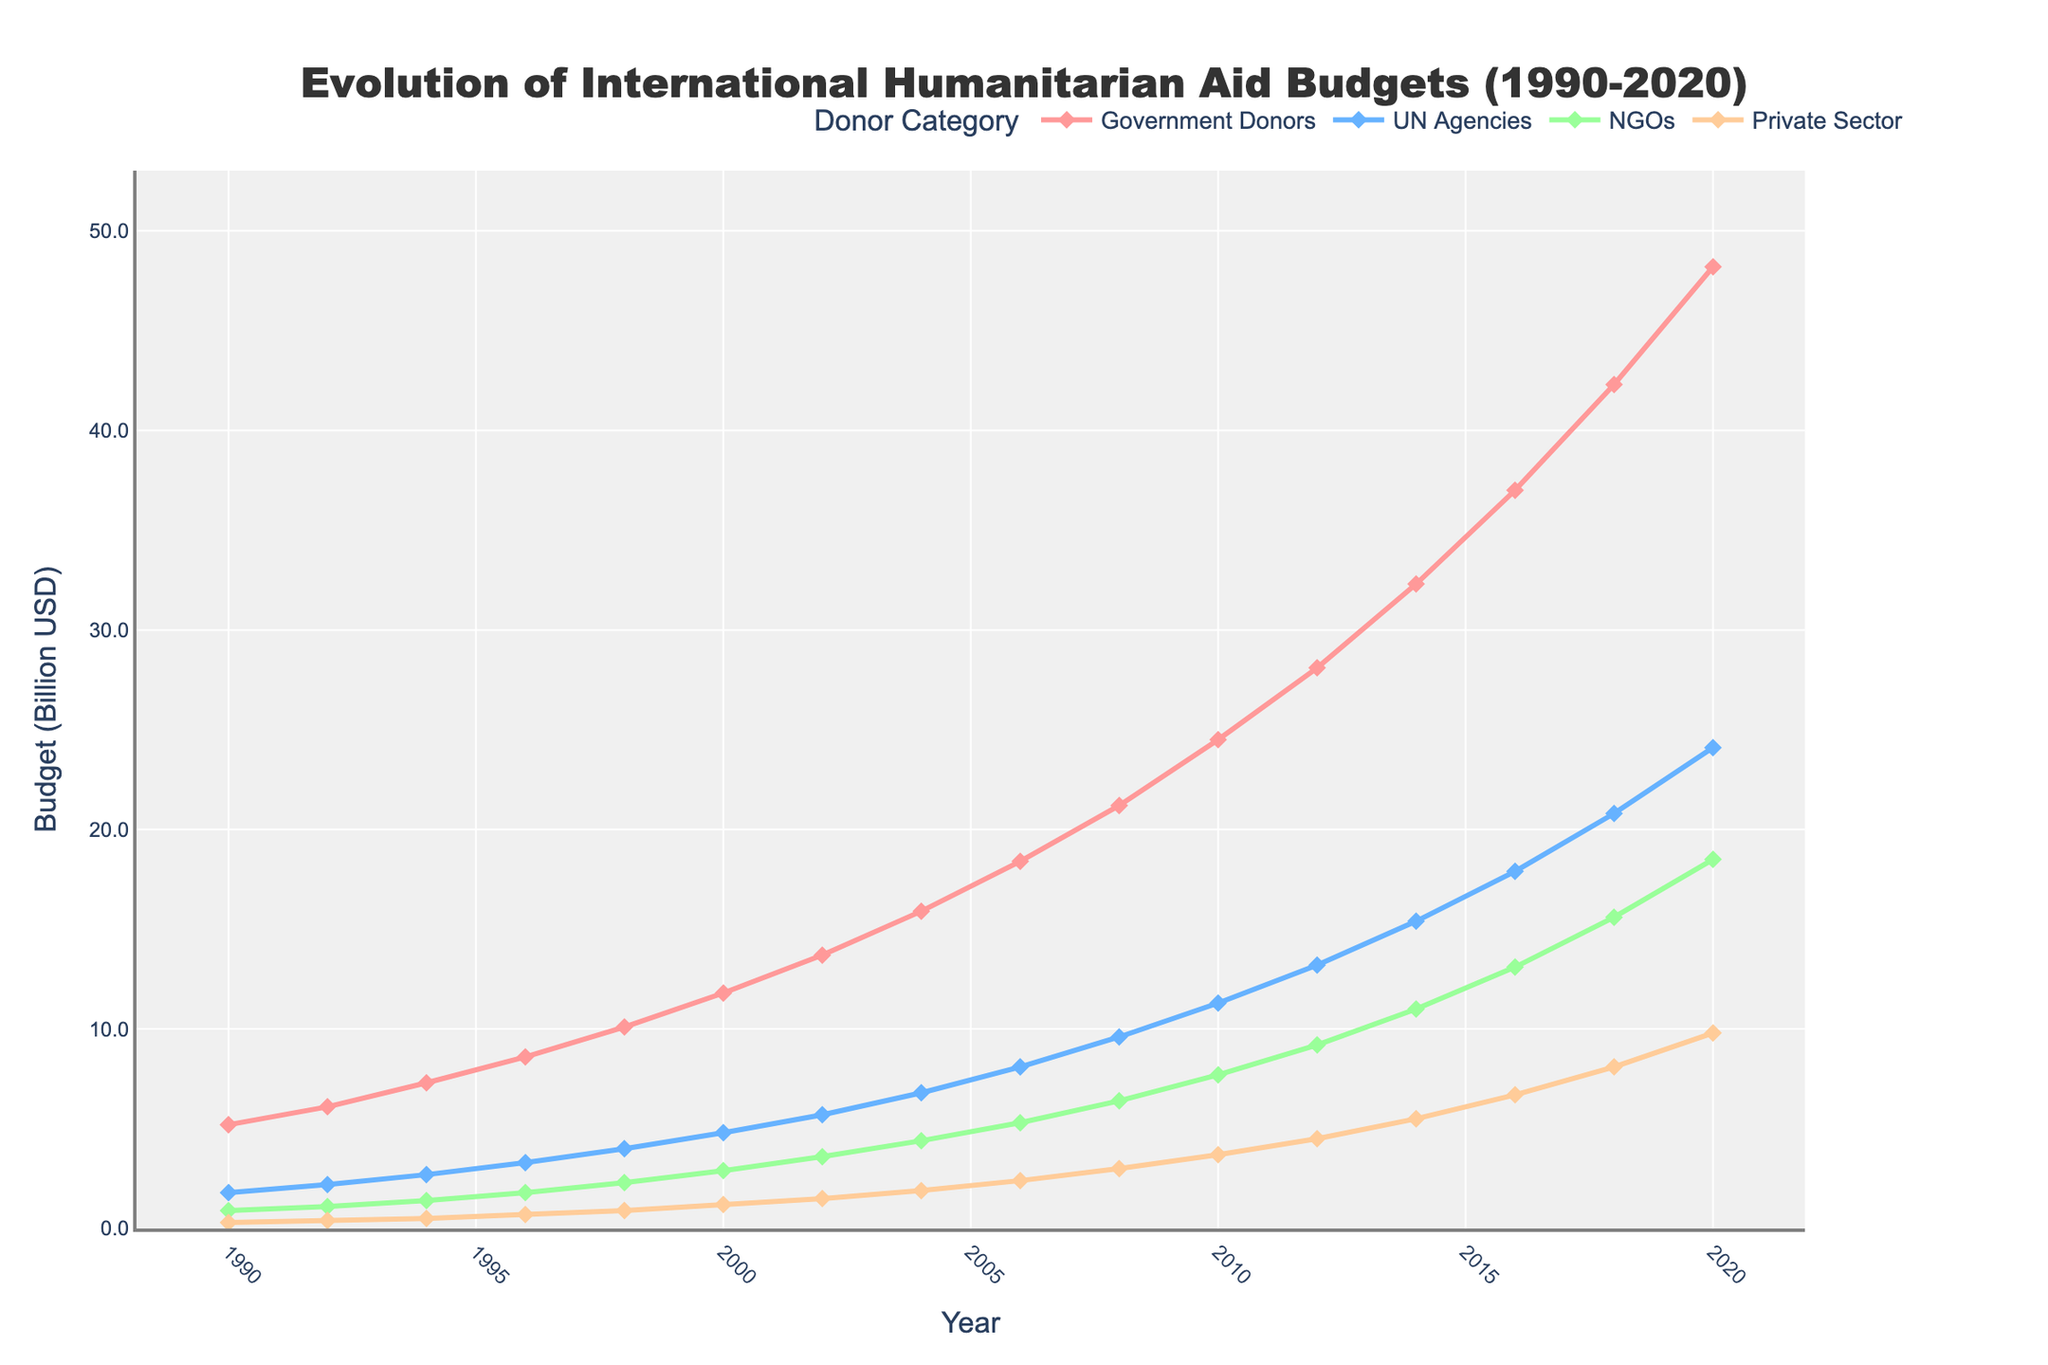What is the total humanitarian aid budget from all donors in 2000? To calculate the total, we sum the budget from Government Donors, UN Agencies, NGOs, and the Private Sector for the year 2000: 11.8 + 4.8 + 2.9 + 1.2 = 20.7
Answer: 20.7 Between 1996 and 2006, which donor category saw the greatest increase in their budget? To determine this, subtract the 1996 budgets from the 2006 budgets for each category: Government Donors (18.4 - 8.6 = 9.8), UN Agencies (8.1 - 3.3 = 4.8), NGOs (5.3 - 1.8 = 3.5), Private Sector (2.4 - 0.7 = 1.7). Government Donors saw the greatest increase of 9.8 billion USD.
Answer: Government Donors Which year does the aid budget from NGOs first exceed that of the Private Sector by more than 2 billion USD? Check the difference between NGOs and the Private Sector for each year: 2004 (4.4 - 1.9 = 2.5). NGOs first exceed the Private Sector by more than 2 billion USD in 2004.
Answer: 2004 What is the average annual budget for the UN Agencies from 1990 to 2020? Add all the annual budgets for UN Agencies and then divide by the number of years (16): (1.8 + 2.2+ 2.7 + 3.3 + 4.0 + 4.8 + 5.7 + 6.8 + 8.1 + 9.6 + 11.3 + 13.2 + 15.4 + 17.9 + 20.8 + 24.1)/16 = 9.46
Answer: 9.46 In which year did the total budget from the Private Sector exceed 7 billion USD? Looking at the data for the Private Sector, the first year the budget exceeds 7 billion USD is 2018, with 8.1 billion USD.
Answer: 2018 Which donor category had the smallest budget in 2016 and by how much? Comparing the 2016 data: Government Donors (37.0), UN Agencies (17.9), NGOs (13.1), Private Sector (6.7). The Private Sector had the smallest budget with 6.7 billion USD.
Answer: Private Sector, 6.7 How does the total budget in 2018 compare to that in 1998? Sum the budgets for all donor categories in both years: Total in 2018 = 42.3 + 20.8 + 15.6 + 8.1 = 86.8; Total in 1998 = 10.1 + 4.0 + 2.3 + 0.9 = 17.3. The total budget in 2018 is 86.8 - 17.3 = 69.5 billion USD more than in 1998.
Answer: 69.5 more What is the difference in the budget for Government Donors between 1990 and 2020? Subtract the 1990 budget from the 2020 budget for Government Donors: 48.2 - 5.2 = 43 billion USD
Answer: 43 